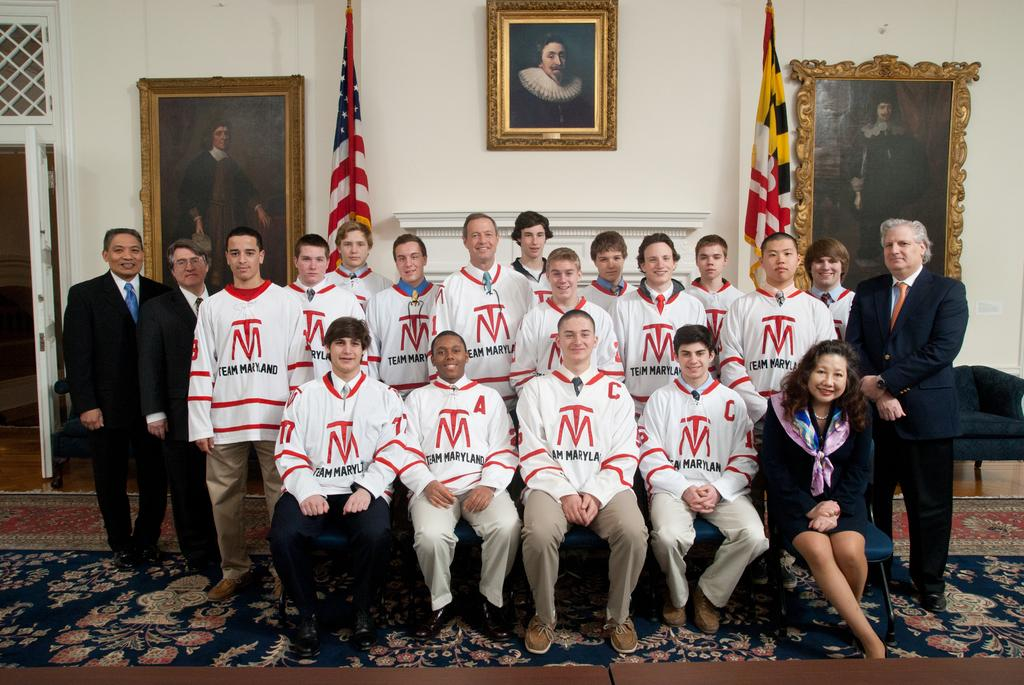<image>
Share a concise interpretation of the image provided. A group of boys wearing Team Maryland jerseys are having their picture taken. 